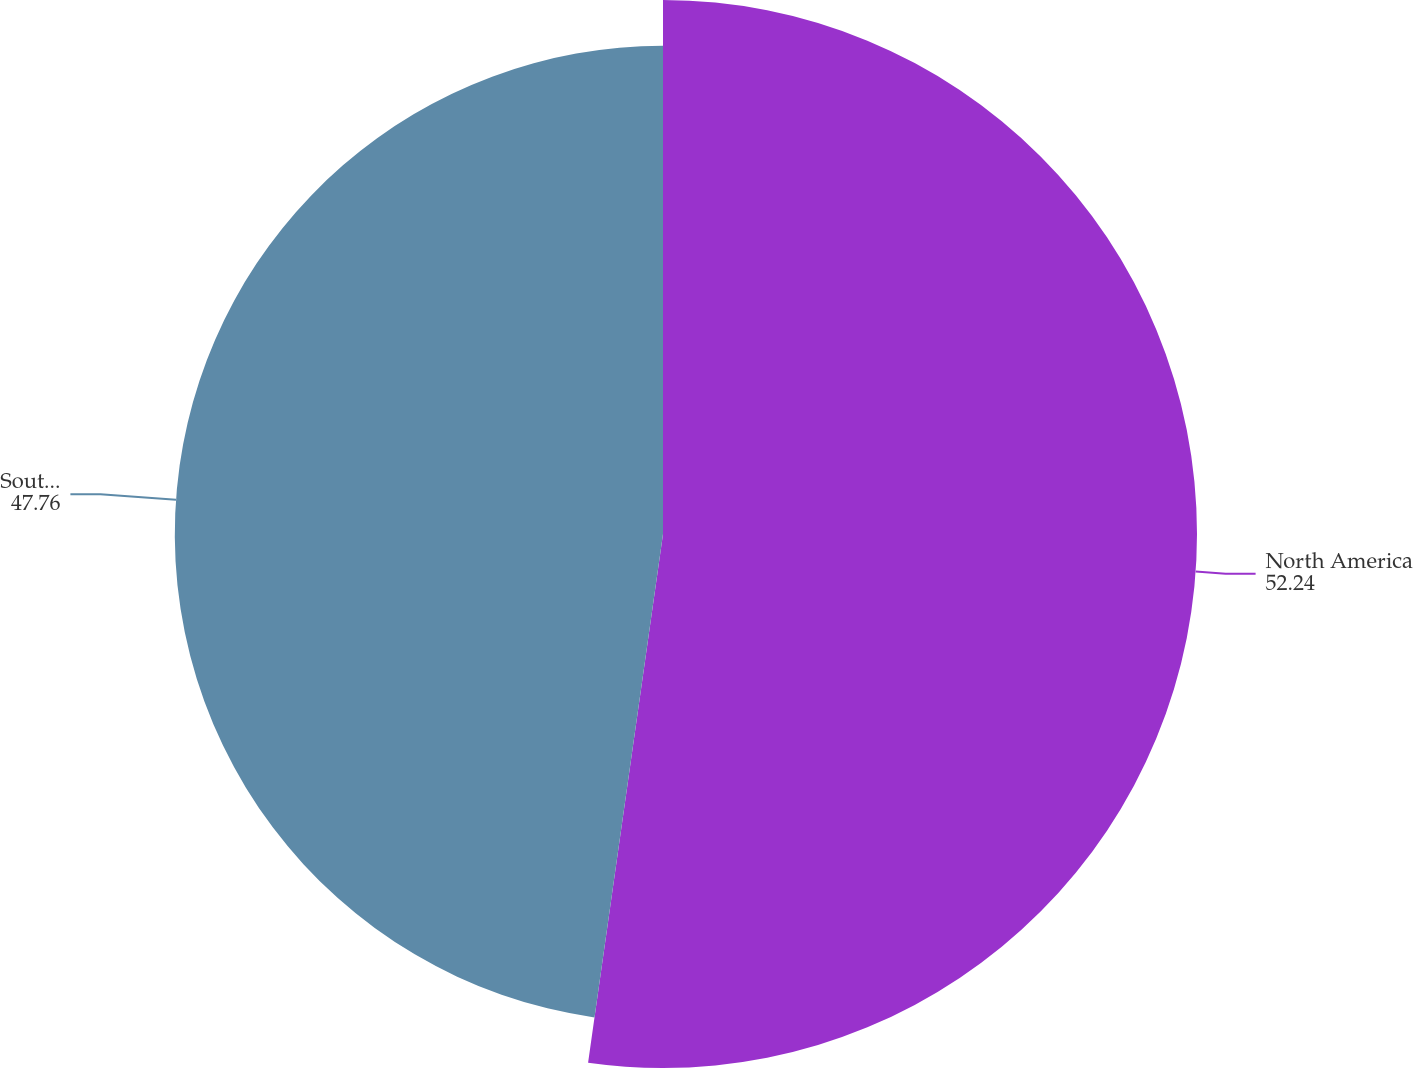<chart> <loc_0><loc_0><loc_500><loc_500><pie_chart><fcel>North America<fcel>South America<nl><fcel>52.24%<fcel>47.76%<nl></chart> 